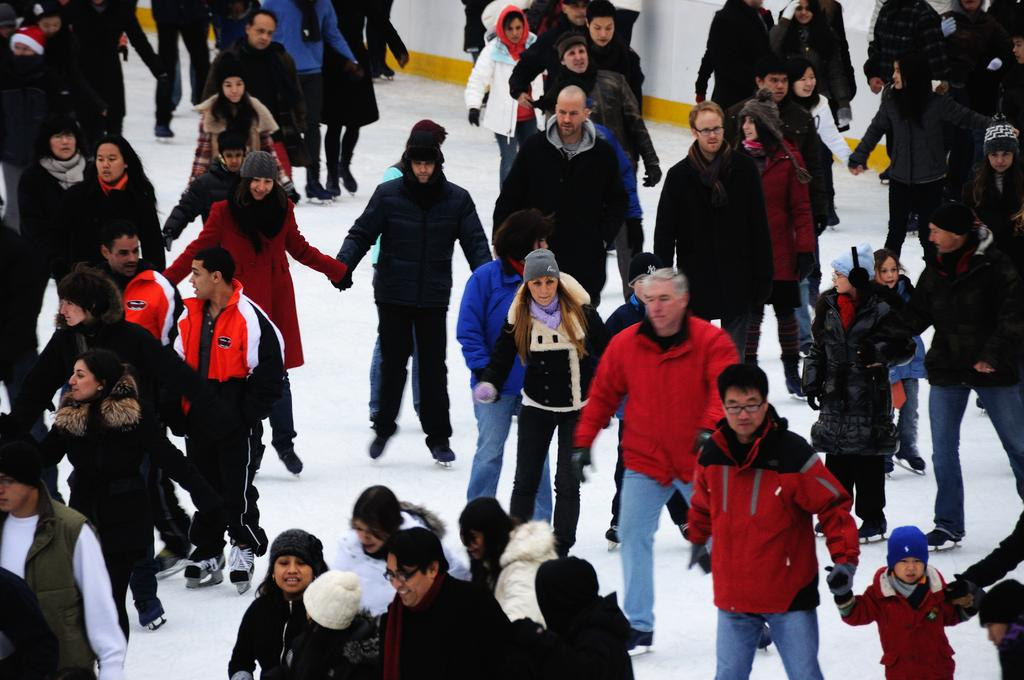What are the people in the image doing? The people in the image are skating on an ice surface. What type of clothing are most of the people wearing? Most of the people are wearing jackets. Can you describe any unique accessories worn by some of the people? A few people are wearing monkey caps on their heads. What type of bird can be seen flying over the sea in the image? There is no bird or sea present in the image; it features a group of people skating on an ice surface. 